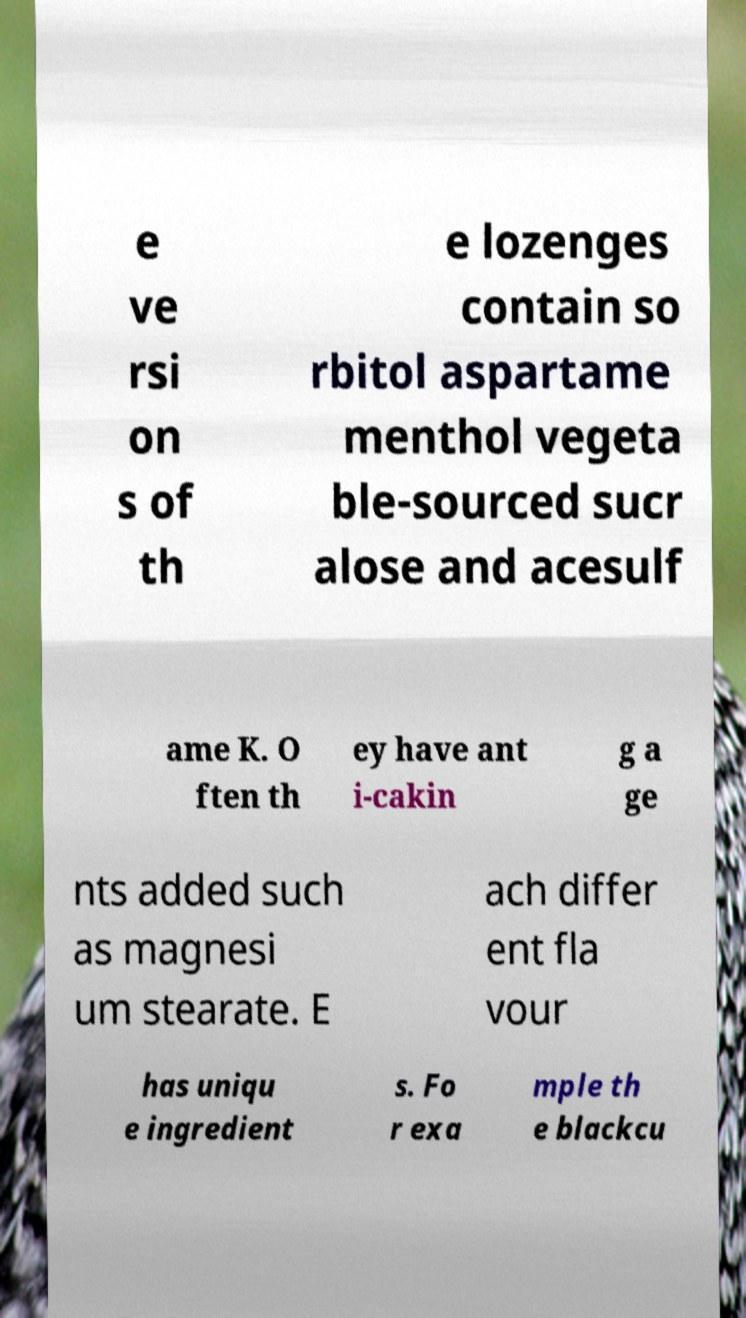Please read and relay the text visible in this image. What does it say? e ve rsi on s of th e lozenges contain so rbitol aspartame menthol vegeta ble-sourced sucr alose and acesulf ame K. O ften th ey have ant i-cakin g a ge nts added such as magnesi um stearate. E ach differ ent fla vour has uniqu e ingredient s. Fo r exa mple th e blackcu 